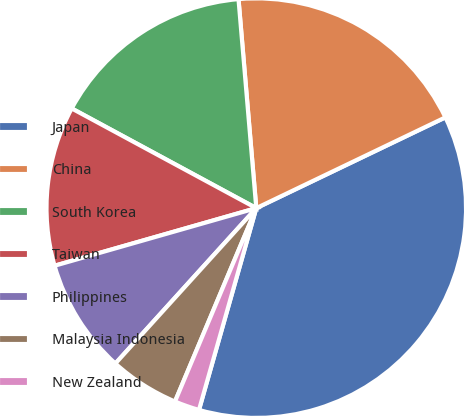Convert chart to OTSL. <chart><loc_0><loc_0><loc_500><loc_500><pie_chart><fcel>Japan<fcel>China<fcel>South Korea<fcel>Taiwan<fcel>Philippines<fcel>Malaysia Indonesia<fcel>New Zealand<nl><fcel>36.53%<fcel>19.23%<fcel>15.77%<fcel>12.31%<fcel>8.85%<fcel>5.39%<fcel>1.93%<nl></chart> 